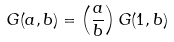Convert formula to latex. <formula><loc_0><loc_0><loc_500><loc_500>G ( a , b ) = \left ( \frac { a } { b } \right ) G ( 1 , b )</formula> 